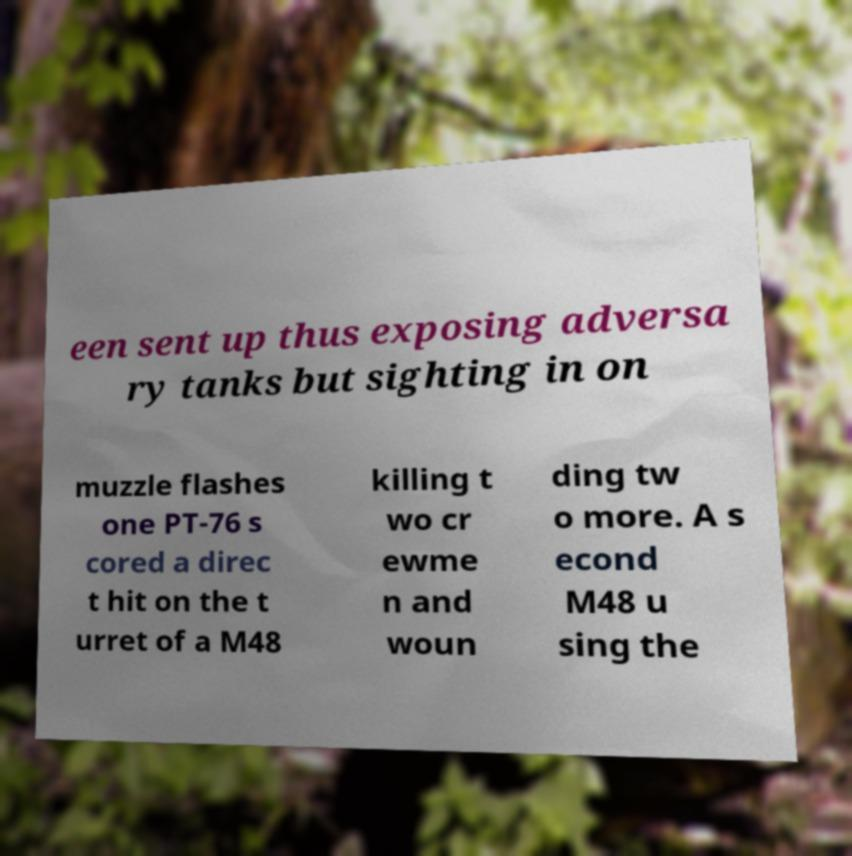Can you accurately transcribe the text from the provided image for me? een sent up thus exposing adversa ry tanks but sighting in on muzzle flashes one PT-76 s cored a direc t hit on the t urret of a M48 killing t wo cr ewme n and woun ding tw o more. A s econd M48 u sing the 